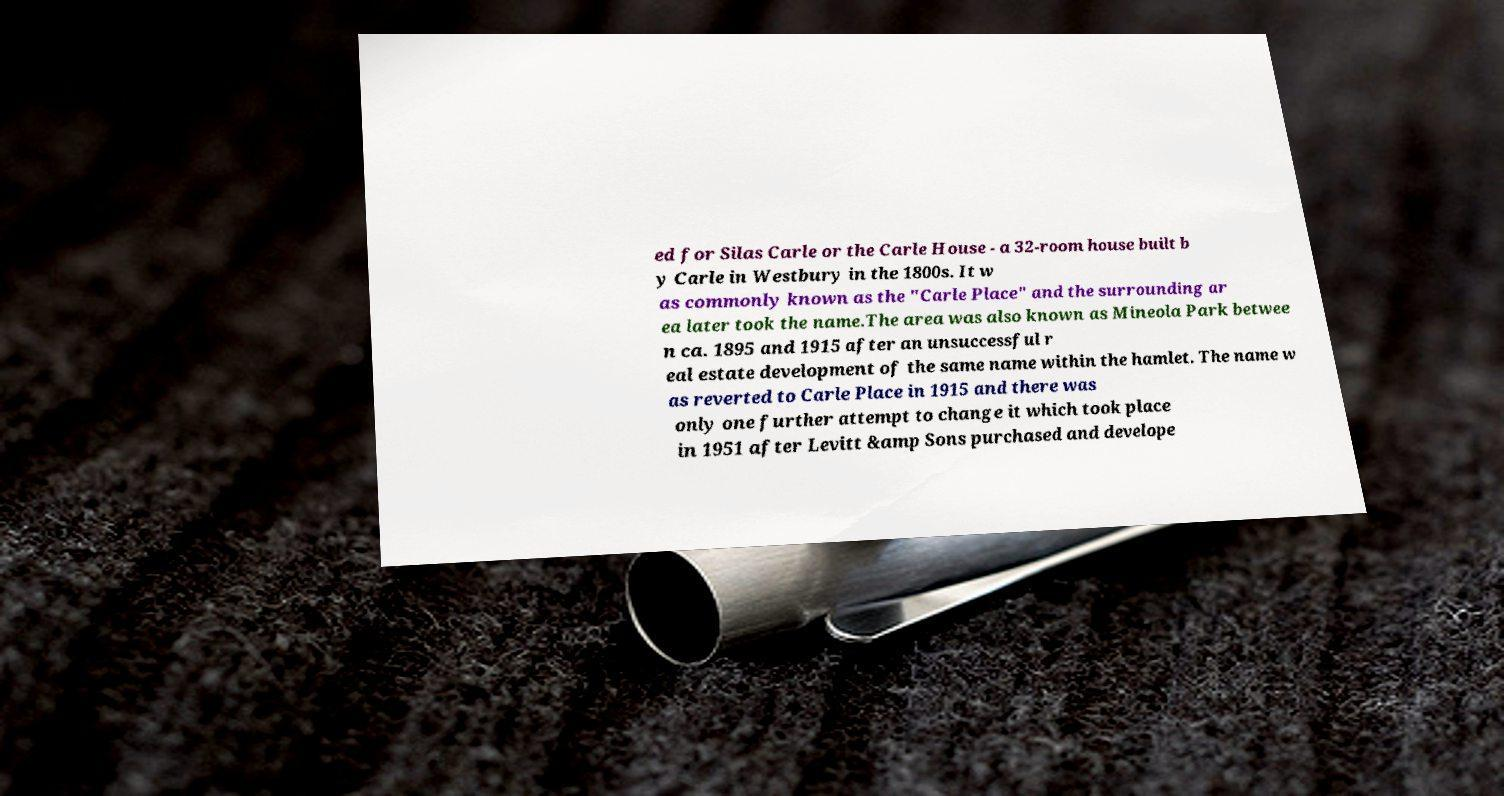What messages or text are displayed in this image? I need them in a readable, typed format. ed for Silas Carle or the Carle House - a 32-room house built b y Carle in Westbury in the 1800s. It w as commonly known as the "Carle Place" and the surrounding ar ea later took the name.The area was also known as Mineola Park betwee n ca. 1895 and 1915 after an unsuccessful r eal estate development of the same name within the hamlet. The name w as reverted to Carle Place in 1915 and there was only one further attempt to change it which took place in 1951 after Levitt &amp Sons purchased and develope 